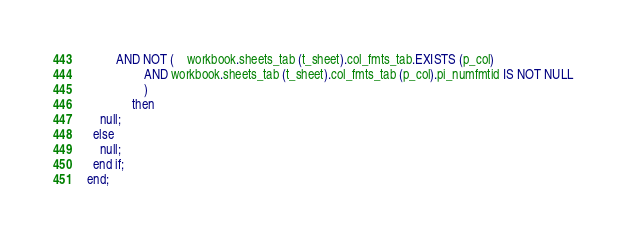Convert code to text. <code><loc_0><loc_0><loc_500><loc_500><_SQL_>         AND NOT (    workbook.sheets_tab (t_sheet).col_fmts_tab.EXISTS (p_col)
                  AND workbook.sheets_tab (t_sheet).col_fmts_tab (p_col).pi_numfmtid IS NOT NULL
                  )
              then
    null;
  else
    null;
  end if;
end;
</code> 